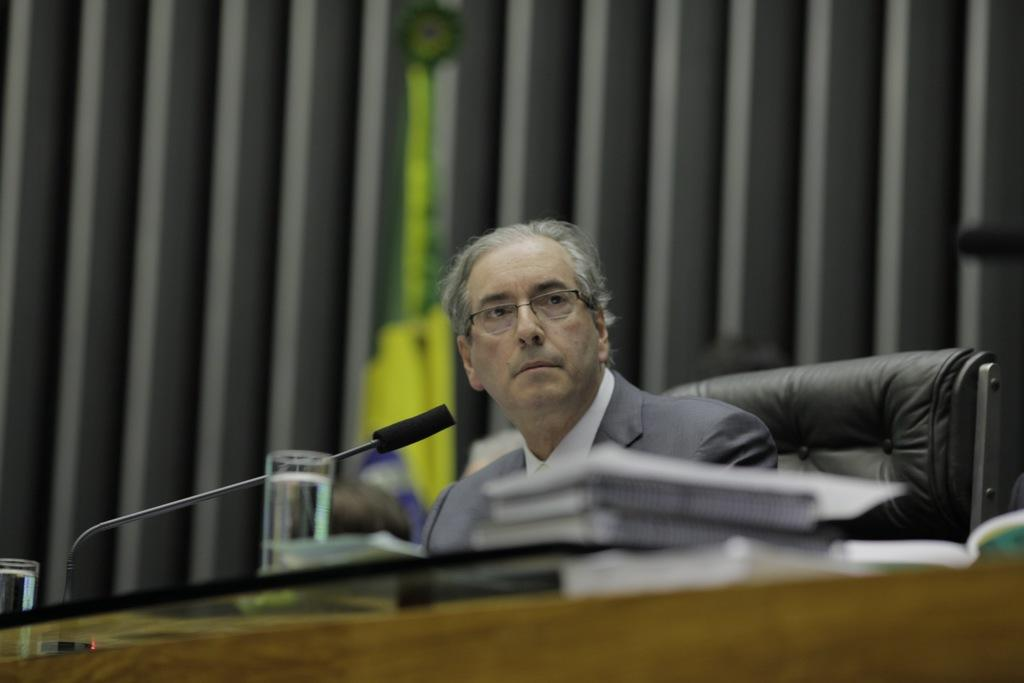What is the man in the image doing? The man is sitting on a chair in the image. What object is present that is typically used for amplifying sound? There is a microphone (mic) in the image. What can be seen on the man's face in the image? There are glasses visible in the image. How many spiders are crawling on the man's arm in the image? There are no spiders visible in the image; the man is wearing glasses and sitting near a microphone. 